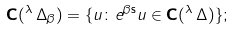<formula> <loc_0><loc_0><loc_500><loc_500>\mathbf C ( { ^ { \lambda } \, \Delta } _ { \beta } ) = \{ u \colon e ^ { \beta \mathsf s } u \in \mathbf C ( { ^ { \lambda } \, \Delta } ) \} ;</formula> 